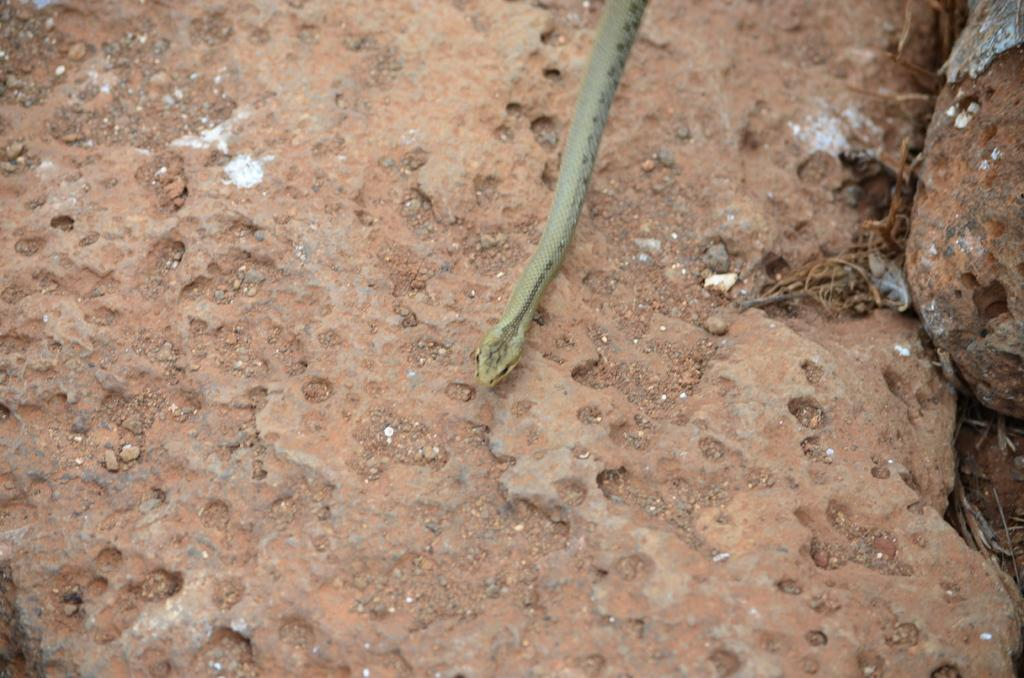What animal is present in the image? There is a snake in the image. What is the snake's position in the image? The snake is lying on the ground. What type of education is the snake pursuing in the image? There is no indication in the image that the snake is pursuing any type of education. 